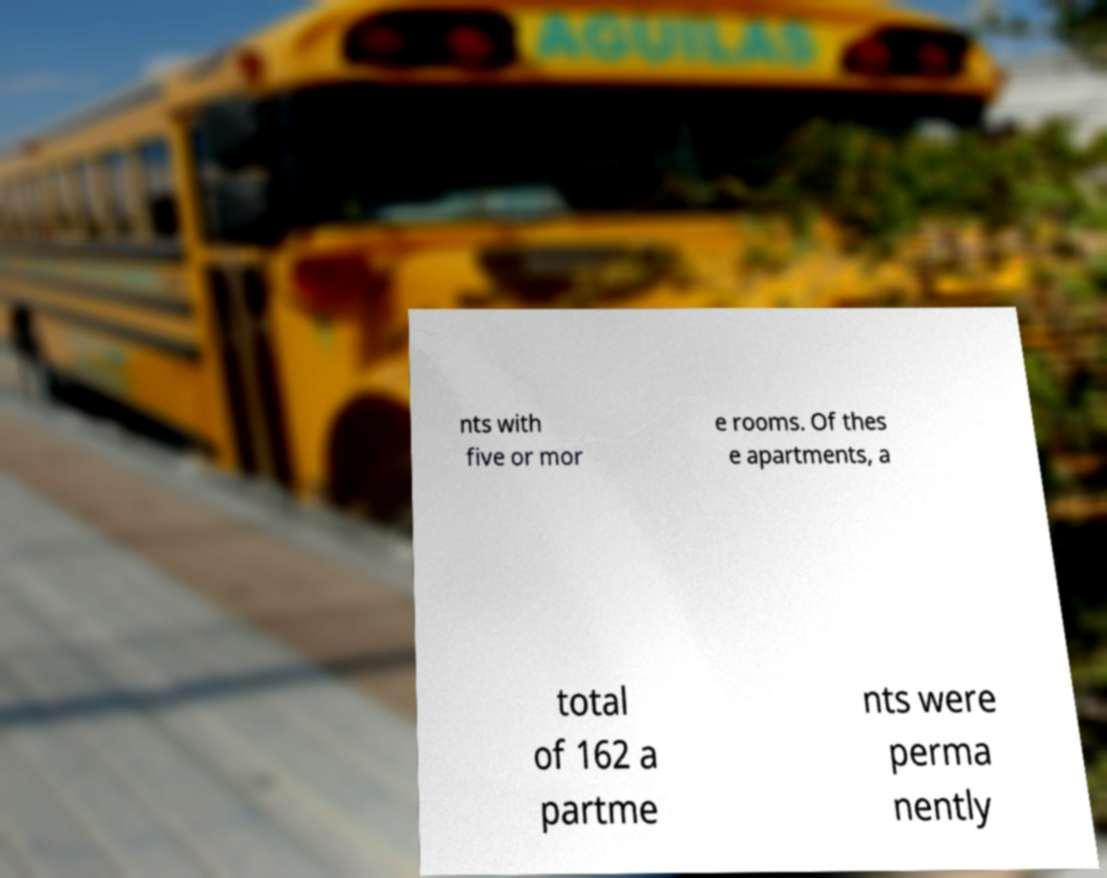Could you extract and type out the text from this image? nts with five or mor e rooms. Of thes e apartments, a total of 162 a partme nts were perma nently 